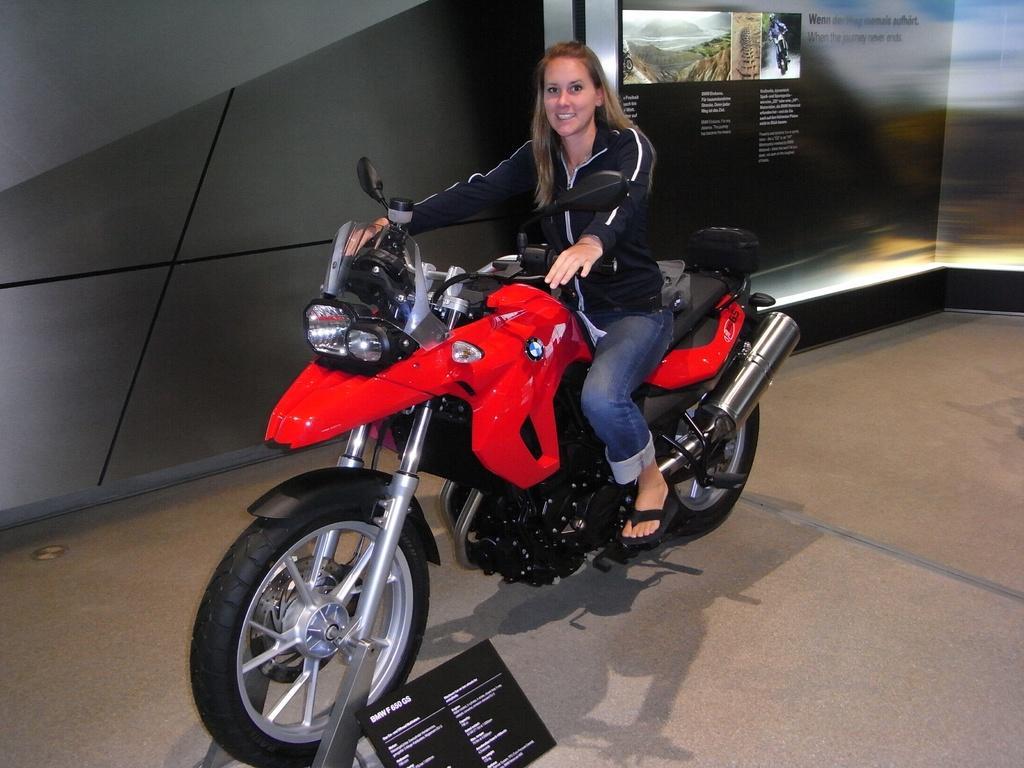Please provide a concise description of this image. In this image we can see woman sitting on the bike. At the background we can see a mountain and a sky. 